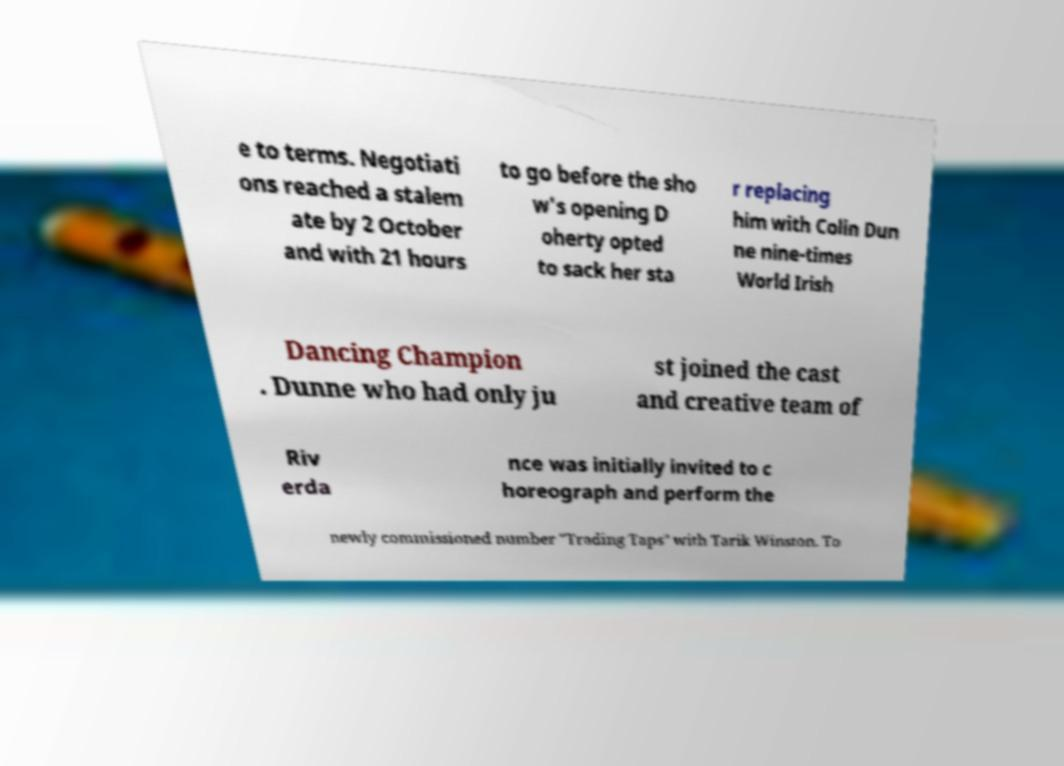Please read and relay the text visible in this image. What does it say? e to terms. Negotiati ons reached a stalem ate by 2 October and with 21 hours to go before the sho w's opening D oherty opted to sack her sta r replacing him with Colin Dun ne nine-times World Irish Dancing Champion . Dunne who had only ju st joined the cast and creative team of Riv erda nce was initially invited to c horeograph and perform the newly commissioned number "Trading Taps" with Tarik Winston. To 